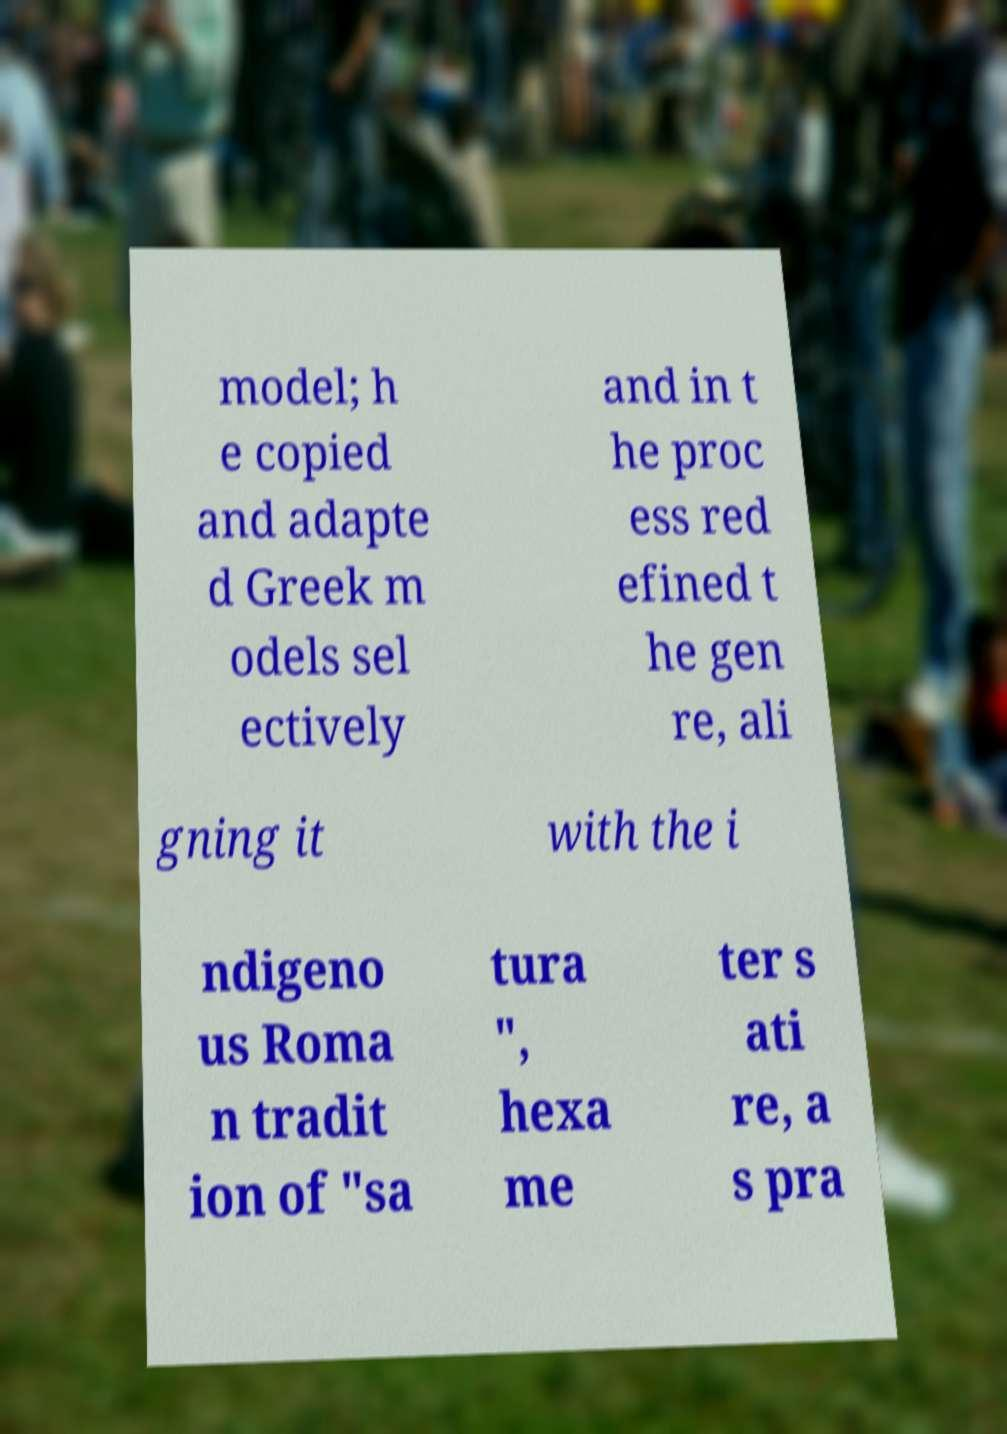Could you assist in decoding the text presented in this image and type it out clearly? model; h e copied and adapte d Greek m odels sel ectively and in t he proc ess red efined t he gen re, ali gning it with the i ndigeno us Roma n tradit ion of "sa tura ", hexa me ter s ati re, a s pra 